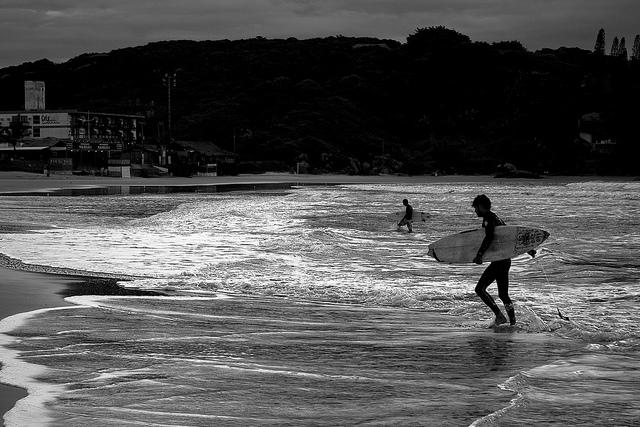What is the problem with this photo?

Choices:
A) too bright
B) blurred
C) photoshopped
D) too dark too dark 